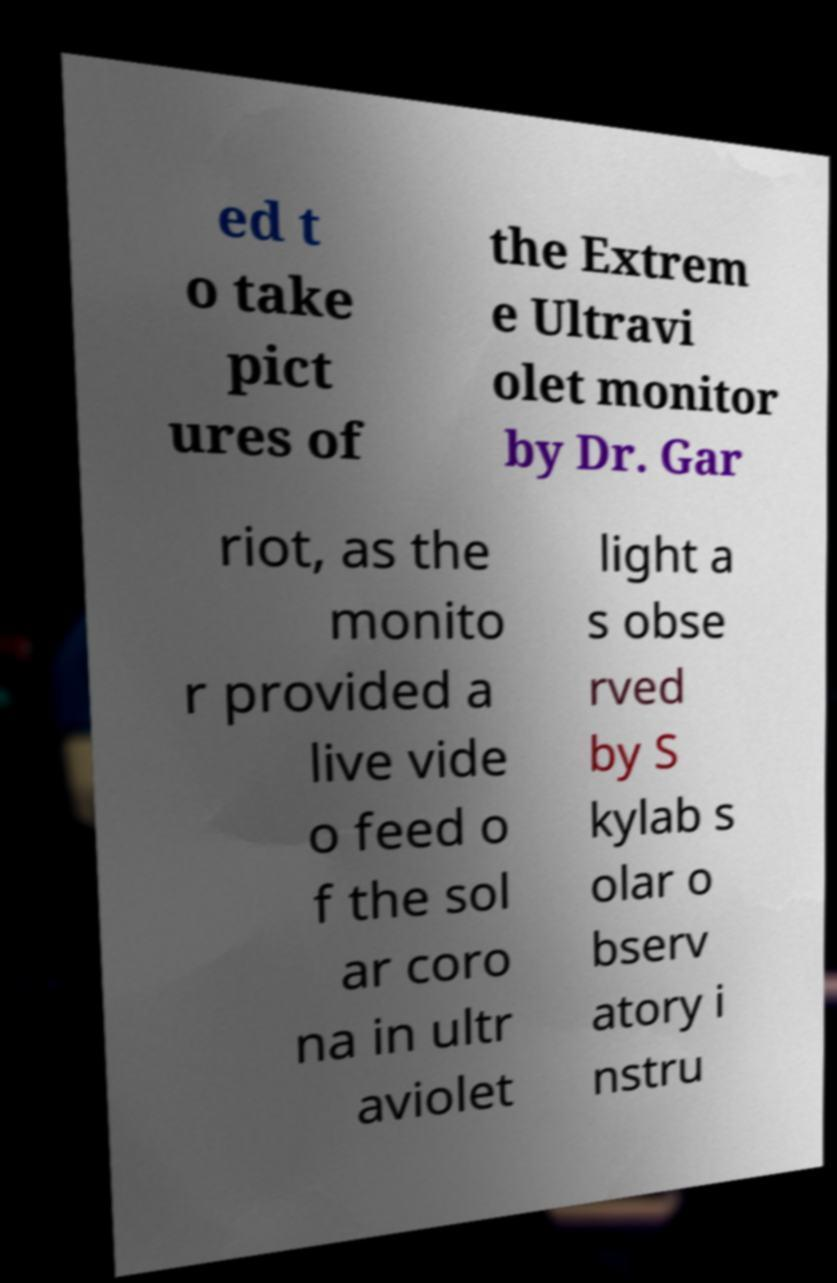Could you extract and type out the text from this image? ed t o take pict ures of the Extrem e Ultravi olet monitor by Dr. Gar riot, as the monito r provided a live vide o feed o f the sol ar coro na in ultr aviolet light a s obse rved by S kylab s olar o bserv atory i nstru 